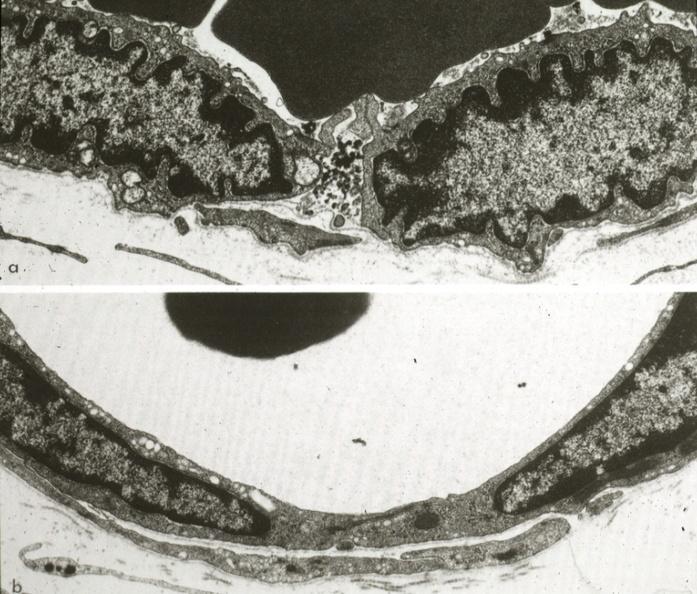where is this mage from?
Answer the question using a single word or phrase. Capillary 